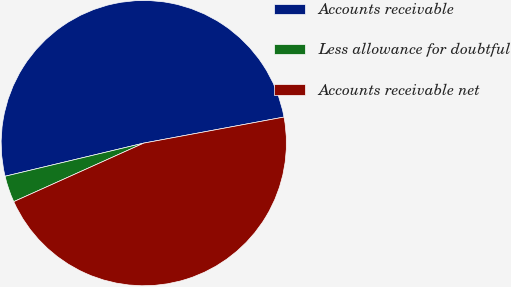Convert chart. <chart><loc_0><loc_0><loc_500><loc_500><pie_chart><fcel>Accounts receivable<fcel>Less allowance for doubtful<fcel>Accounts receivable net<nl><fcel>50.81%<fcel>3.0%<fcel>46.19%<nl></chart> 